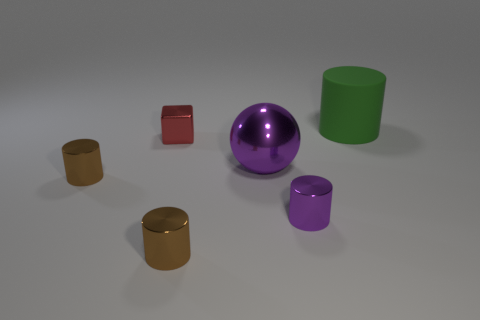How many brown cylinders are made of the same material as the big purple ball?
Offer a terse response. 2. Is the material of the small red thing that is to the left of the purple metallic ball the same as the green cylinder?
Give a very brief answer. No. Is the number of tiny brown objects that are behind the green thing greater than the number of small cubes that are to the right of the tiny shiny block?
Your answer should be very brief. No. There is a green thing that is the same size as the metal ball; what is it made of?
Make the answer very short. Rubber. How many other things are there of the same material as the sphere?
Your response must be concise. 4. Do the big object left of the large matte object and the tiny purple object in front of the large purple metal object have the same shape?
Your answer should be very brief. No. How many other objects are there of the same color as the tiny shiny cube?
Your answer should be compact. 0. Is the material of the large object that is in front of the big matte cylinder the same as the brown thing in front of the small purple cylinder?
Your answer should be compact. Yes. Are there the same number of objects behind the big purple ball and large green rubber cylinders that are on the left side of the tiny purple object?
Make the answer very short. No. There is a purple object to the right of the ball; what material is it?
Make the answer very short. Metal. 